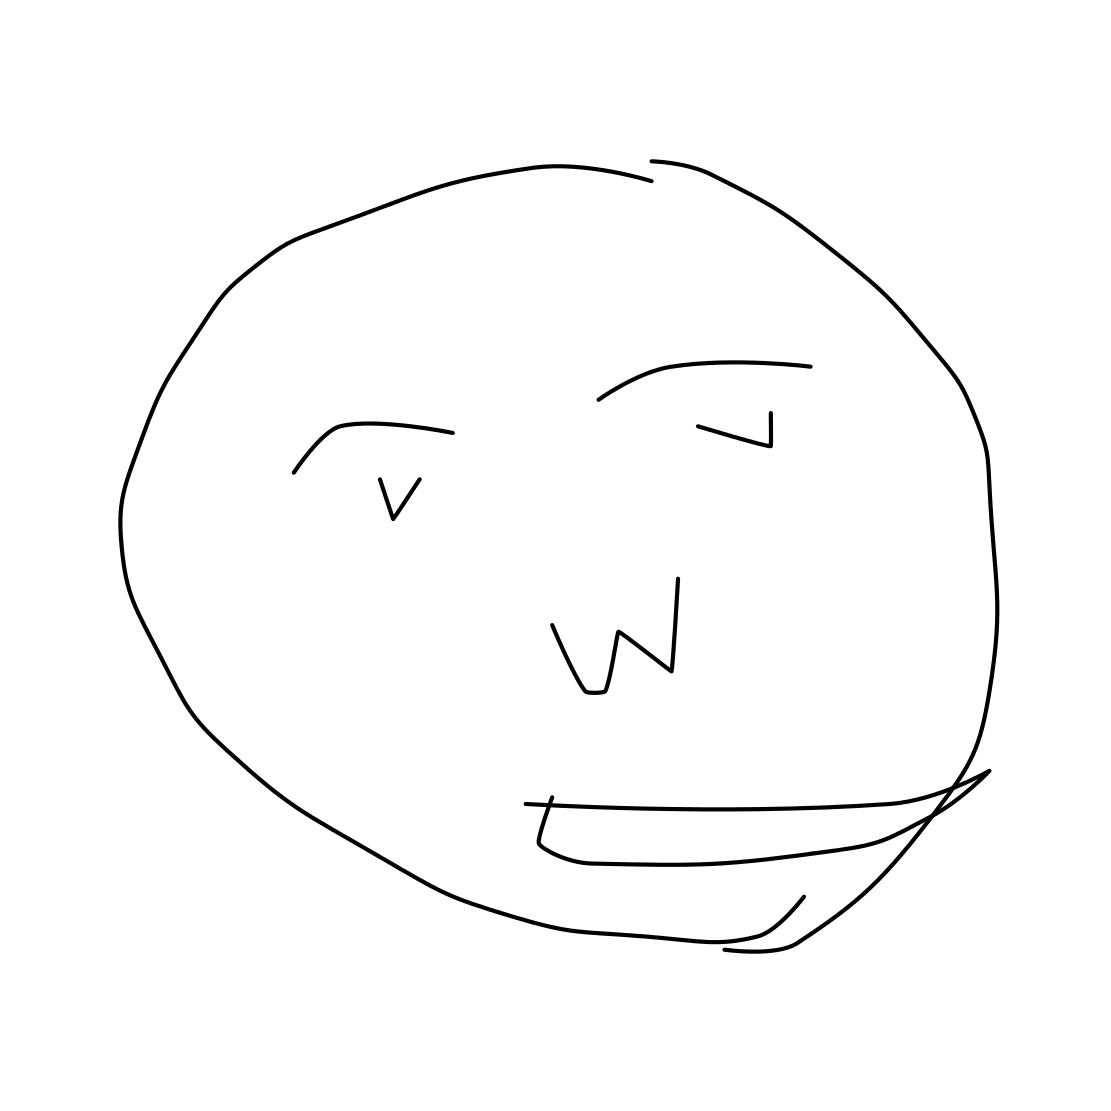What emotions do you think are conveyed by the face in this image? The face in the image appears to convey a cheerful or happy emotion, suggested by the upward curve of the mouth which resembles a smile. 